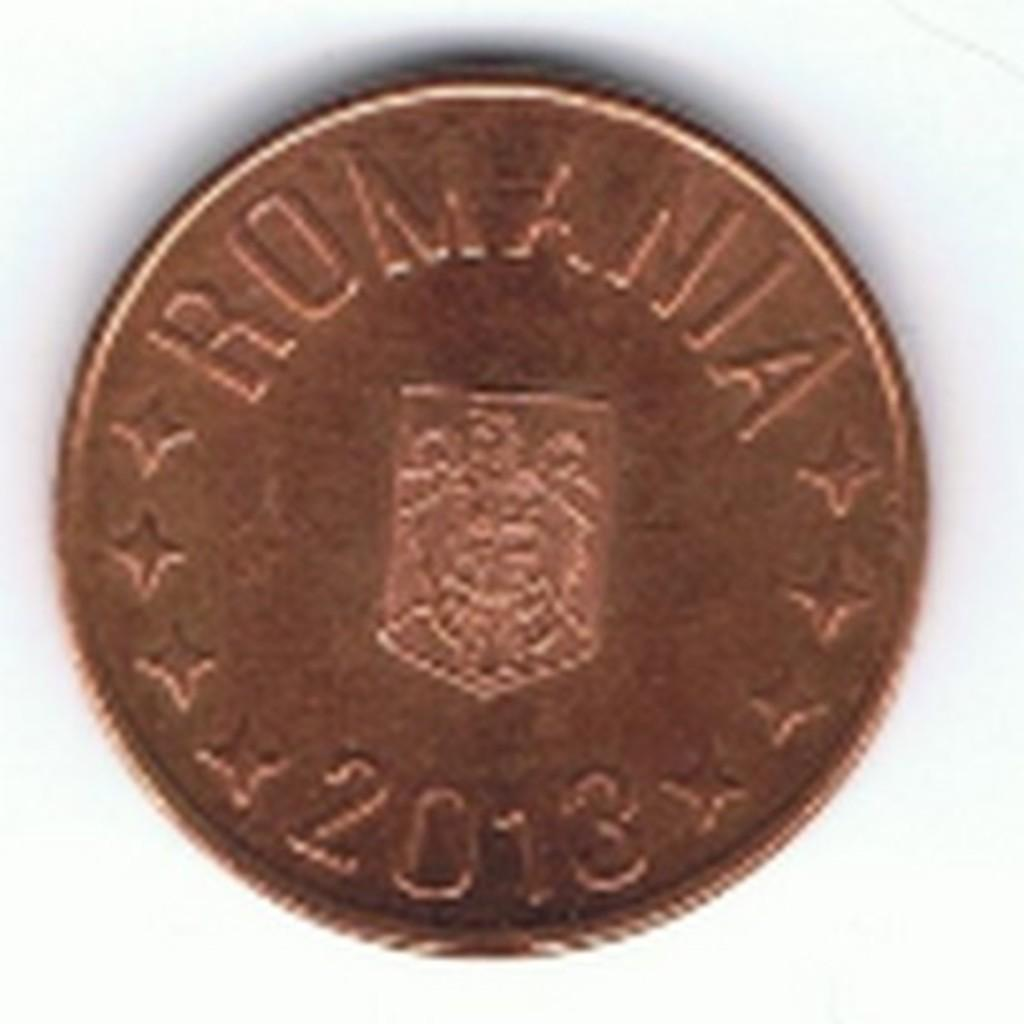<image>
Render a clear and concise summary of the photo. A copper coin with the inscription "Romania 2013" 